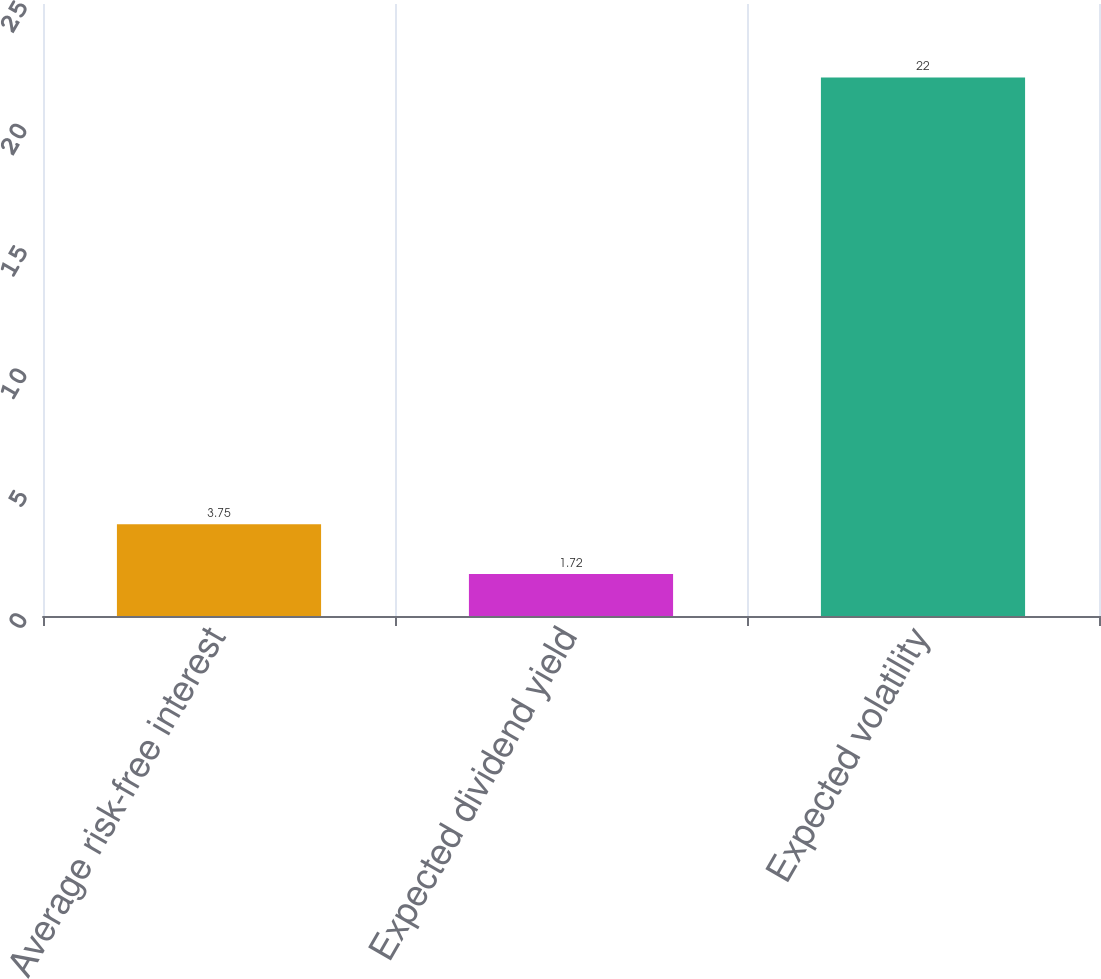Convert chart to OTSL. <chart><loc_0><loc_0><loc_500><loc_500><bar_chart><fcel>Average risk-free interest<fcel>Expected dividend yield<fcel>Expected volatility<nl><fcel>3.75<fcel>1.72<fcel>22<nl></chart> 